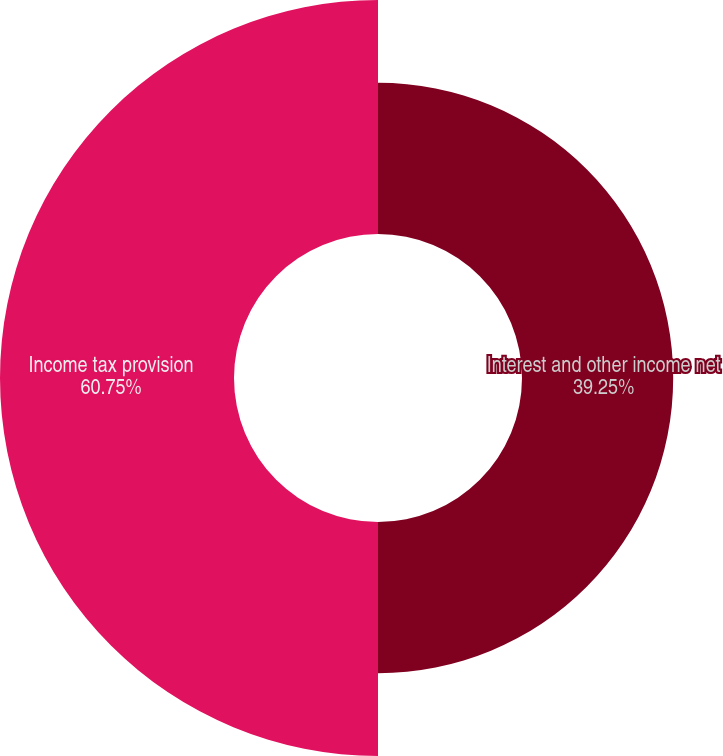<chart> <loc_0><loc_0><loc_500><loc_500><pie_chart><fcel>Interest and other income net<fcel>Income tax provision<nl><fcel>39.25%<fcel>60.75%<nl></chart> 